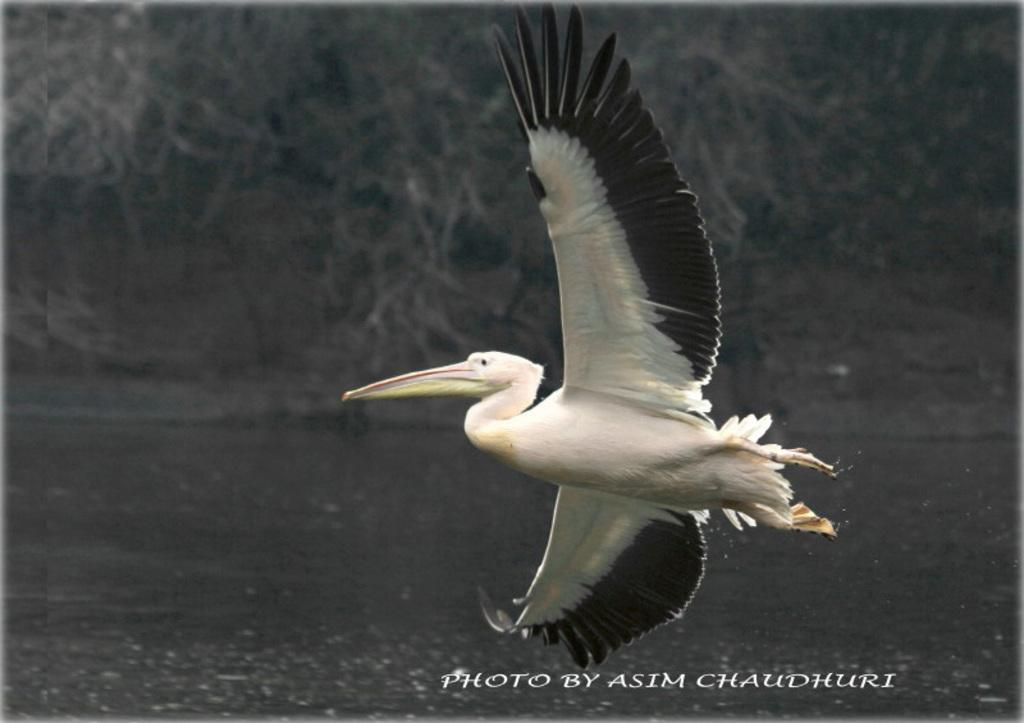What is the main subject of the image? There is a bird flying in the image. What can be seen in the background of the image? There are trees and water visible in the background of the image. What type of form does the bird use to skate on the water in the image? There is no bird skating on the water in the image; it is flying. What knowledge can be gained from the image about the bird's ability to acquire new skills? The image does not provide any information about the bird's ability to acquire new skills, as it only shows the bird flying. 